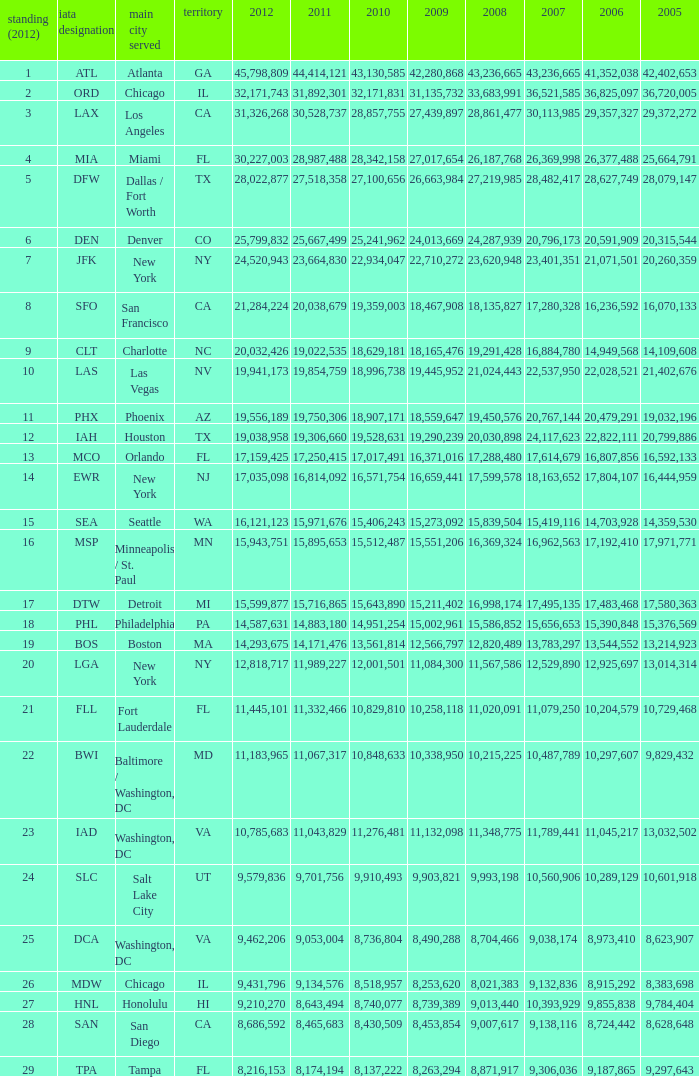For the IATA code of lax with 2009 less than 31,135,732 and 2011 less than 8,174,194, what is the sum of 2012? 0.0. 